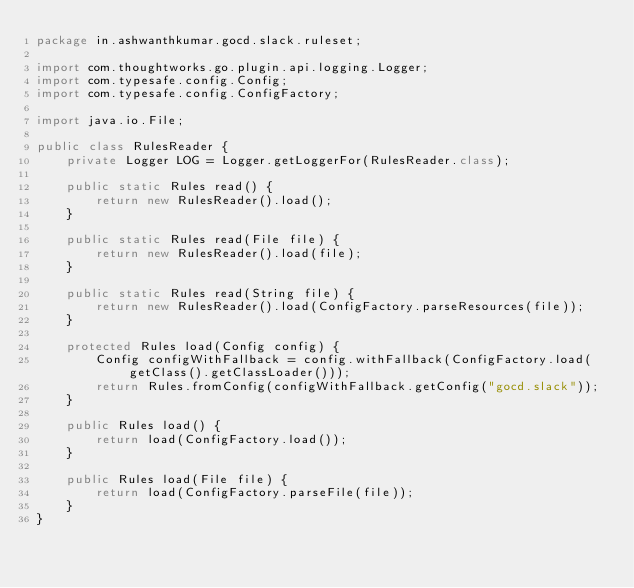<code> <loc_0><loc_0><loc_500><loc_500><_Java_>package in.ashwanthkumar.gocd.slack.ruleset;

import com.thoughtworks.go.plugin.api.logging.Logger;
import com.typesafe.config.Config;
import com.typesafe.config.ConfigFactory;

import java.io.File;

public class RulesReader {
    private Logger LOG = Logger.getLoggerFor(RulesReader.class);

    public static Rules read() {
        return new RulesReader().load();
    }

    public static Rules read(File file) {
        return new RulesReader().load(file);
    }

    public static Rules read(String file) {
        return new RulesReader().load(ConfigFactory.parseResources(file));
    }

    protected Rules load(Config config) {
        Config configWithFallback = config.withFallback(ConfigFactory.load(getClass().getClassLoader()));
        return Rules.fromConfig(configWithFallback.getConfig("gocd.slack"));
    }

    public Rules load() {
        return load(ConfigFactory.load());
    }

    public Rules load(File file) {
        return load(ConfigFactory.parseFile(file));
    }
}
</code> 